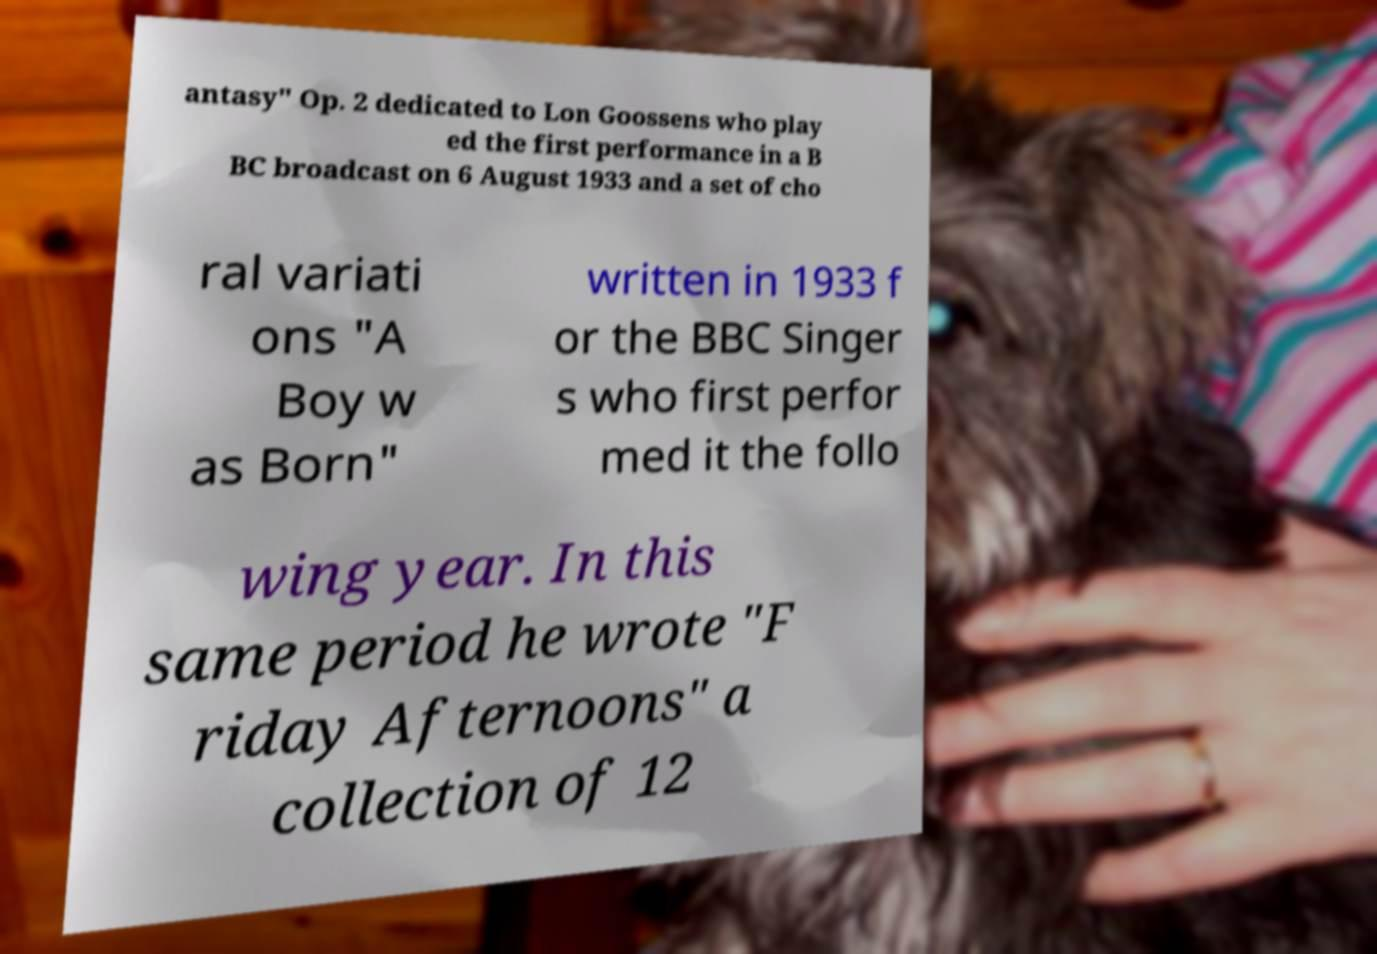Please read and relay the text visible in this image. What does it say? antasy" Op. 2 dedicated to Lon Goossens who play ed the first performance in a B BC broadcast on 6 August 1933 and a set of cho ral variati ons "A Boy w as Born" written in 1933 f or the BBC Singer s who first perfor med it the follo wing year. In this same period he wrote "F riday Afternoons" a collection of 12 